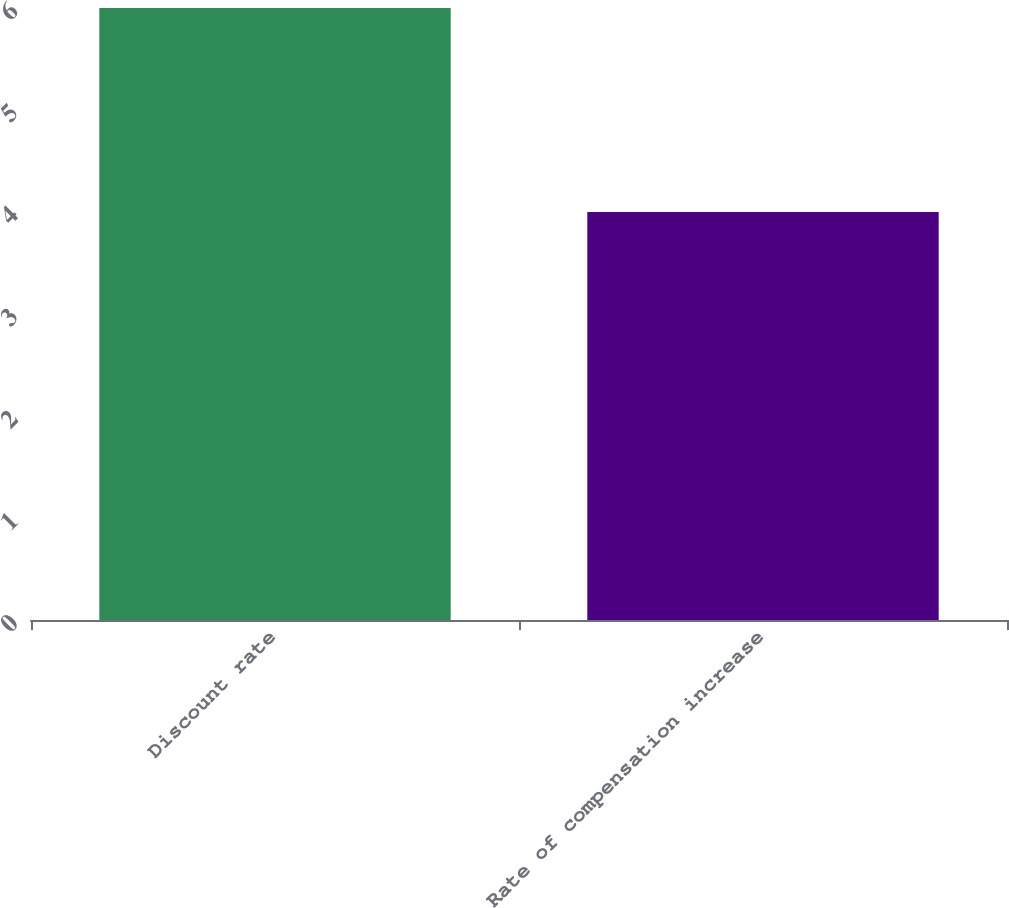Convert chart. <chart><loc_0><loc_0><loc_500><loc_500><bar_chart><fcel>Discount rate<fcel>Rate of compensation increase<nl><fcel>6<fcel>4<nl></chart> 